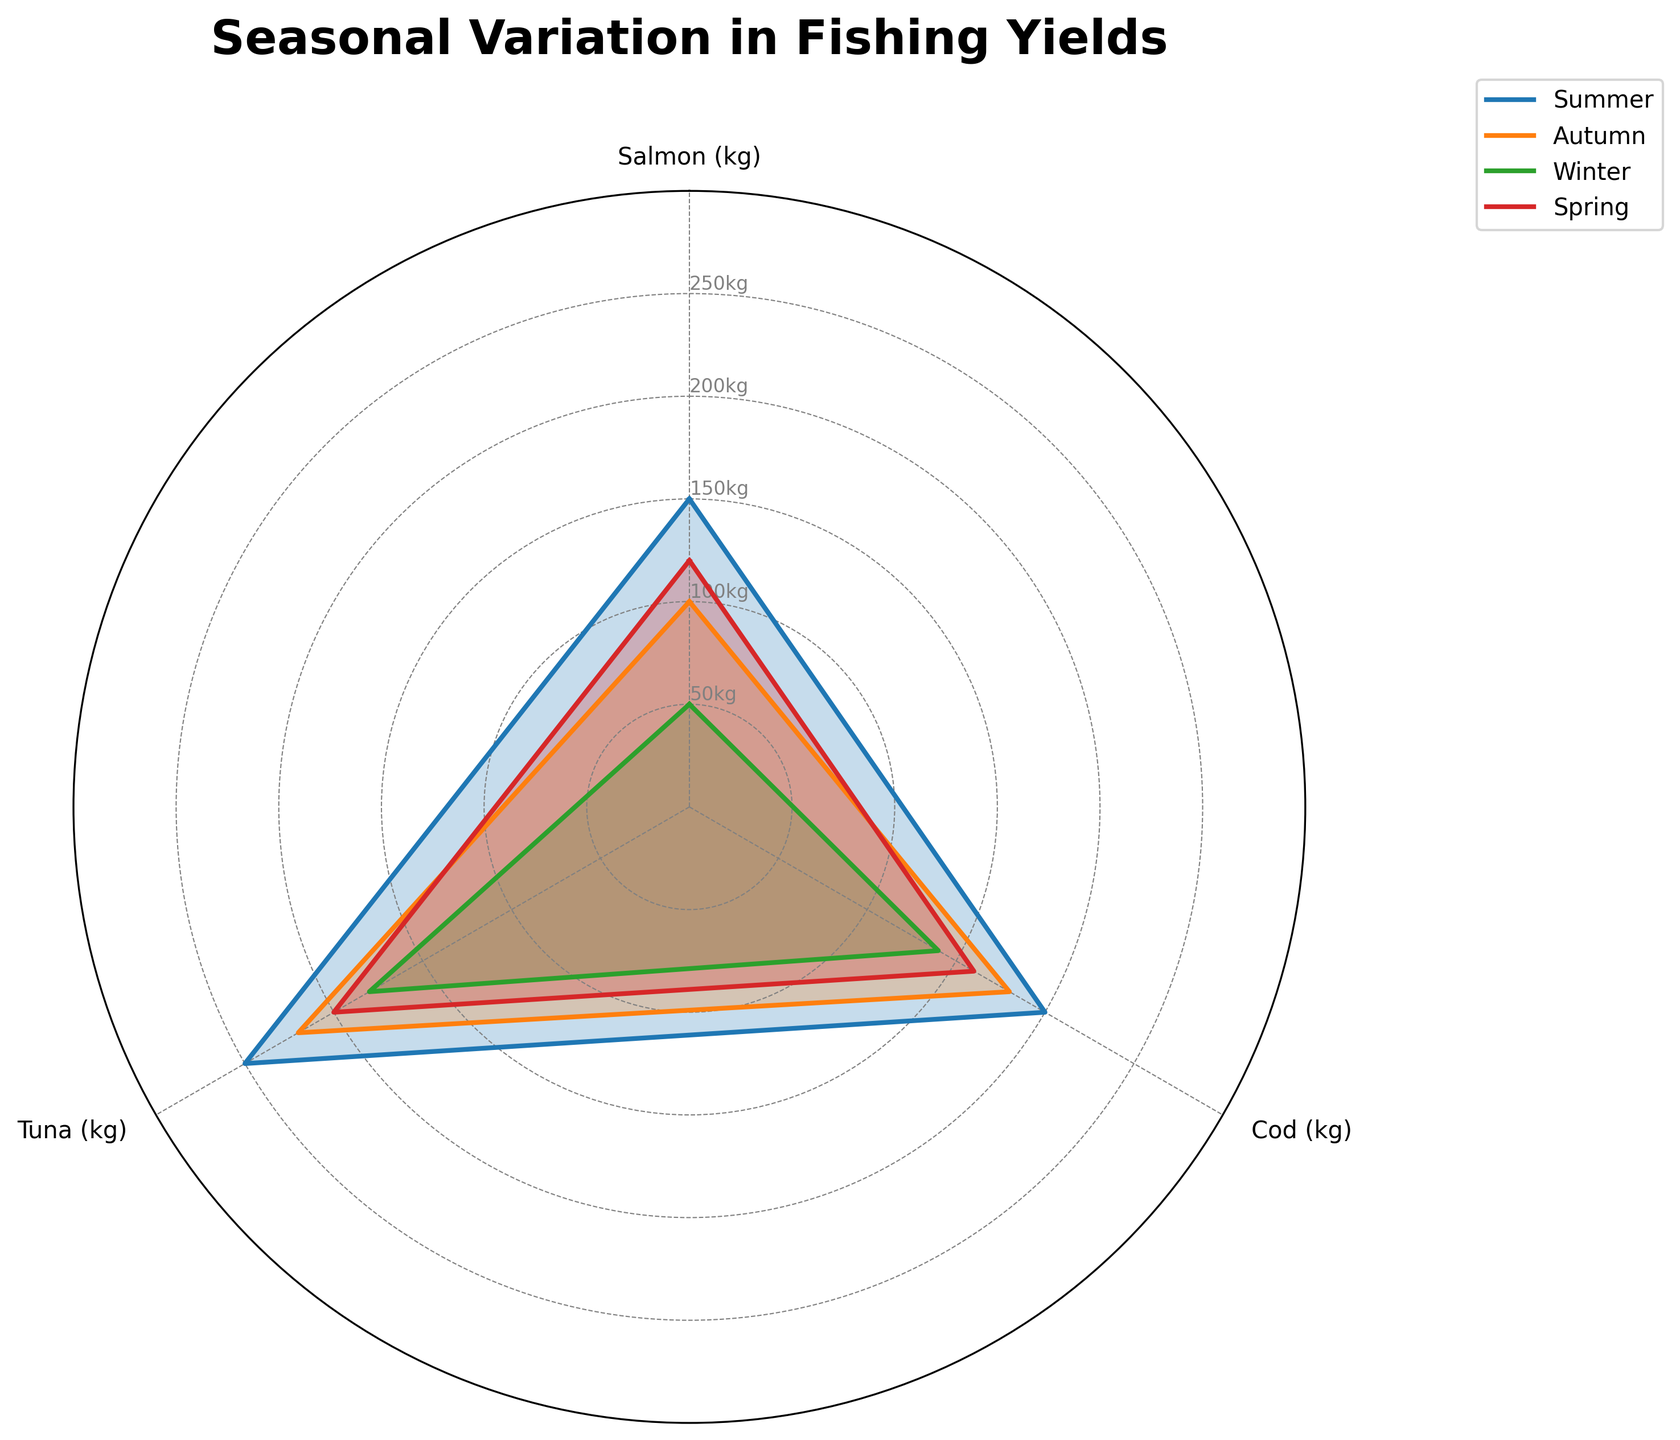Which season shows the highest yield for Salmon? From the plotted values in the radar chart, the line for Summer is the highest at the Salmon axis, reaching 150kg.
Answer: Summer What is the total yield of Cod in Autumn and Winter? The Cod yield for Autumn is 180kg and for Winter is 140kg. Adding these gives 180 + 140 = 320.
Answer: 320kg How much greater is the yield of Tuna in Summer compared to Winter? In Summer, the Tuna yield is 250kg, while in Winter it is 180kg. Subtracting these values gives 250 - 180 = 70.
Answer: 70kg Which season has the lowest overall yield? By examining the yields for each season across all fish types, Winter has the lowest yields: 50kg for Salmon, 140kg for Cod, and 180kg for Tuna.
Answer: Winter Compare the yields of Tuna and Cod in Spring and determine which is higher. In Spring, the yield for Tuna is 200kg, and for Cod, it is 160kg. Tuna yield is higher by comparing the values directly.
Answer: Tuna What is the average yield for all fish types in Spring? The yields in Spring are 120kg for Salmon, 160kg for Cod, and 200kg for Tuna. The sum is 120 + 160 + 200 = 480. Dividing by 3 gives 480/3 = 160.
Answer: 160kg What is the most consistent yield across seasons for Cod? By observing the Cod values in the radar chart, the yields are 200kg (Summer), 180kg (Autumn), 140kg (Winter), 160kg (Spring). The slight variations indicate consistency, with most yields around the higher 180-200kg range.
Answer: High Sum the yields of all fish types in Summer. The yields in Summer are 150kg for Salmon, 200kg for Cod, and 250kg for Tuna. Adding these values gives 150 + 200 + 250 = 600.
Answer: 600kg Does any season show equal yields for two different fish types? By examining each season in the radar chart, no two fish yields are equal within any single season.
Answer: No 